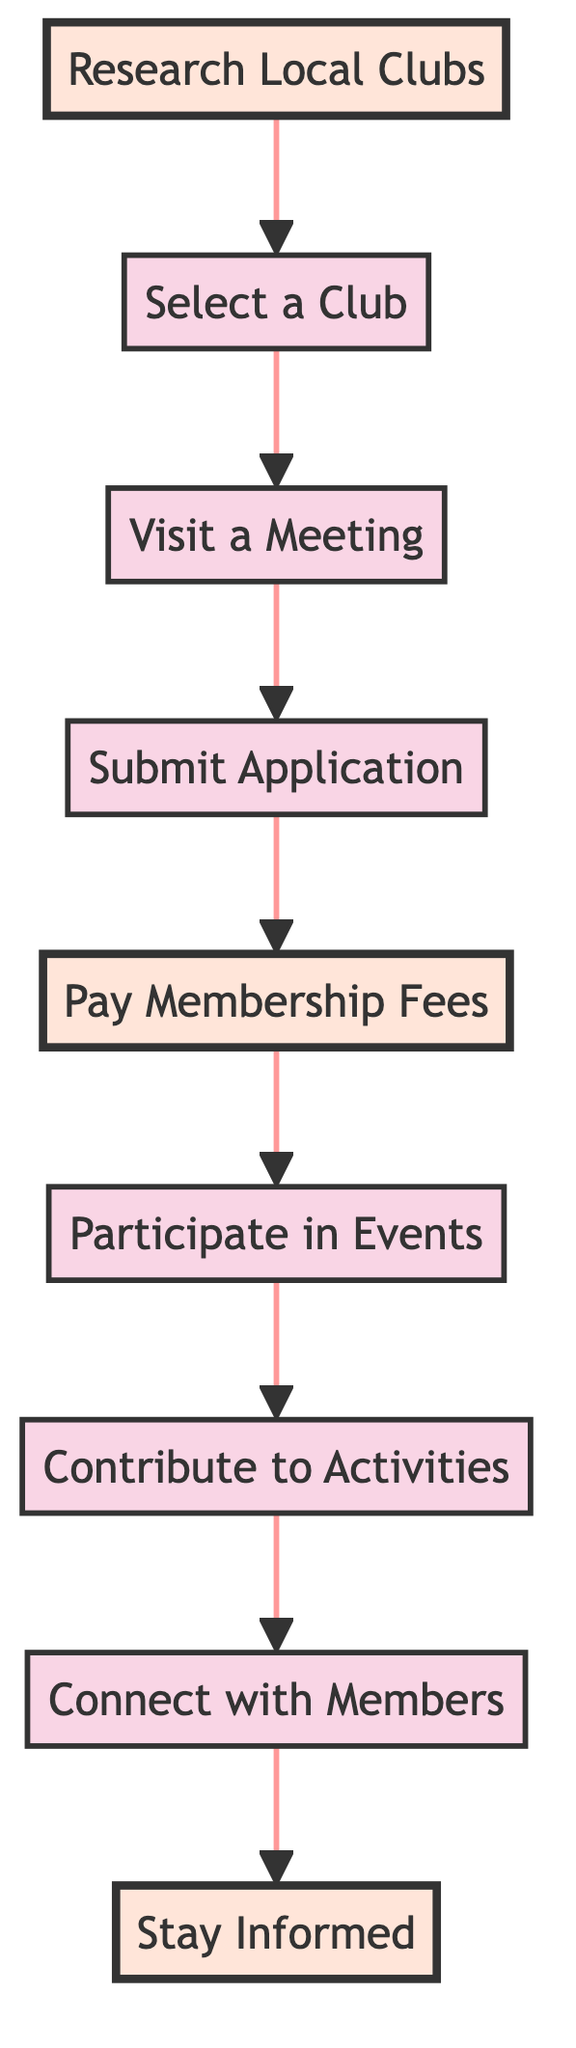What is the first step to join a foodie club? The first step, as indicated in the diagram, is "Research Local Clubs." This information can be found in the first node of the flow chart.
Answer: Research Local Clubs How many total steps are shown in the diagram? By counting the nodes in the flow chart, there are a total of 9 steps listed, which include actions from researching clubs to staying informed.
Answer: 9 What do you do after visiting a meeting? After visiting a meeting, the next step in the diagram is to "Submit Application," which follows immediately after the "Visit a Meeting" node.
Answer: Submit Application What is the membership fee for the Gourmet Society? According to the information provided in the description of the "Pay Membership Fees" step, the Gourmet Society charges $50 annually for membership.
Answer: $50 What is the last step in the process? The last step indicated in the flow chart is "Stay Informed," which is the final node following all previous activities.
Answer: Stay Informed Which step involves networking with fellow foodies? The step that focuses on networking with fellow foodies is "Connect with Members." This can be found directly after the "Contribute to Activities" step.
Answer: Connect with Members How many highlighted steps are there? The diagram highlights 3 specific steps: "Research Local Clubs," "Pay Membership Fees," and "Stay Informed." By counting the highlighted steps, we find that there are 3.
Answer: 3 What is required before participating in events? Before participating in events, one must complete the step of "Pay Membership Fees," as this is a prerequisite for attending events according to the flow of the diagram.
Answer: Pay Membership Fees What action should you take after selecting a club? After selecting a club, the next action to take is to "Visit a Meeting," as outlined by the arrows connecting the nodes in the flow chart.
Answer: Visit a Meeting 